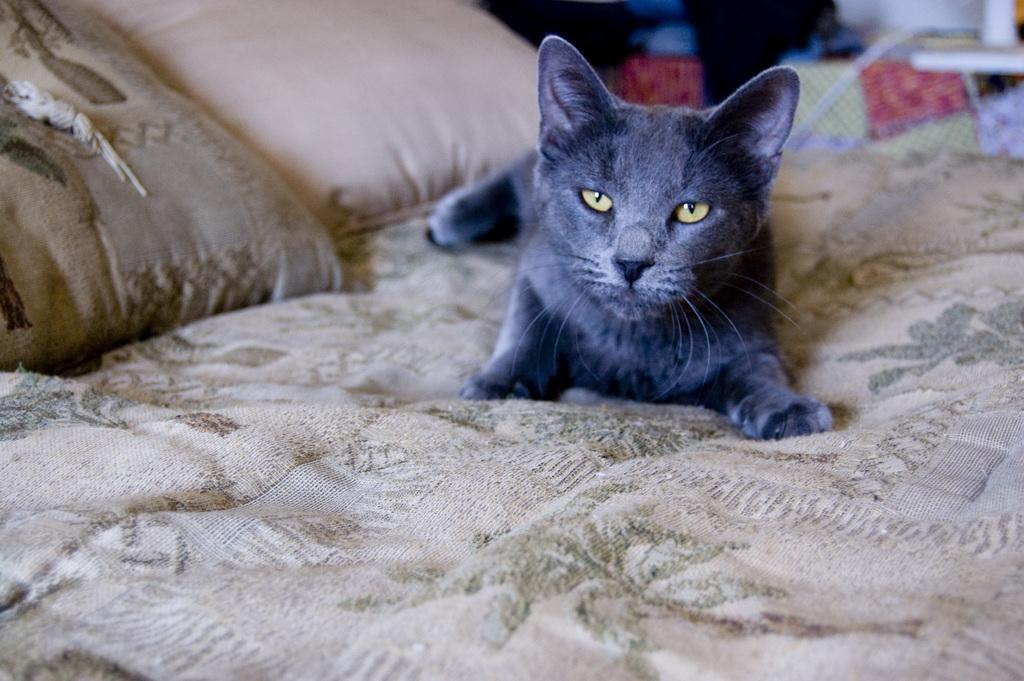What animal is present in the image? There is a cat in the image. Where is the cat located? The cat is on the bed. What is the color of the cat? The cat is black in color. What can be seen in the background of the image? There is a table in the background of the image. What is the color of the wall in the image? The wall is white in color. How many spiders are crawling on the bridge in the image? There is no bridge or spiders present in the image; it features a black cat on a bed. Is the camera visible in the image? There is no camera present in the image. 